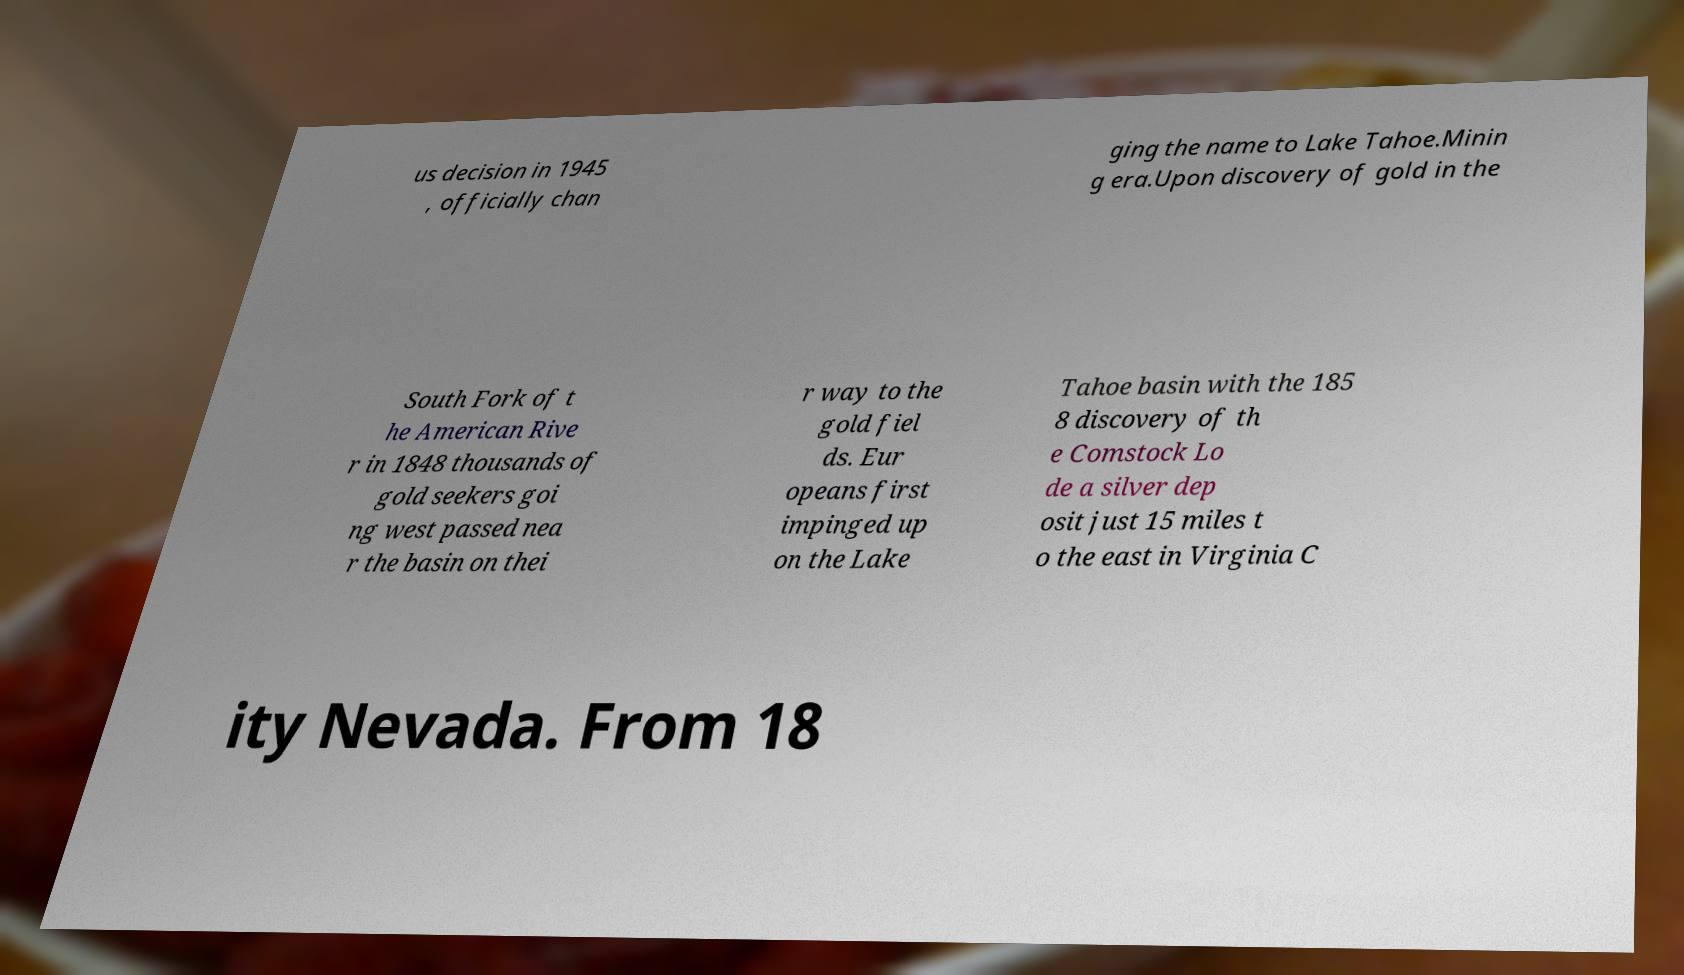There's text embedded in this image that I need extracted. Can you transcribe it verbatim? us decision in 1945 , officially chan ging the name to Lake Tahoe.Minin g era.Upon discovery of gold in the South Fork of t he American Rive r in 1848 thousands of gold seekers goi ng west passed nea r the basin on thei r way to the gold fiel ds. Eur opeans first impinged up on the Lake Tahoe basin with the 185 8 discovery of th e Comstock Lo de a silver dep osit just 15 miles t o the east in Virginia C ity Nevada. From 18 